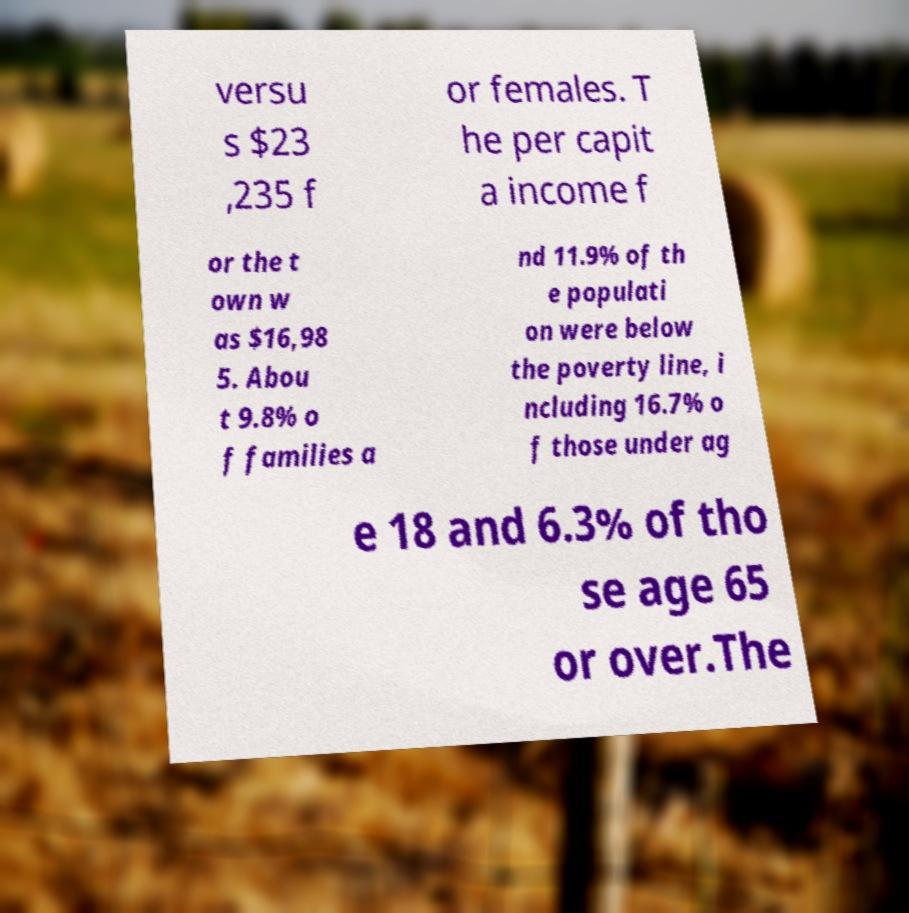Can you read and provide the text displayed in the image?This photo seems to have some interesting text. Can you extract and type it out for me? versu s $23 ,235 f or females. T he per capit a income f or the t own w as $16,98 5. Abou t 9.8% o f families a nd 11.9% of th e populati on were below the poverty line, i ncluding 16.7% o f those under ag e 18 and 6.3% of tho se age 65 or over.The 